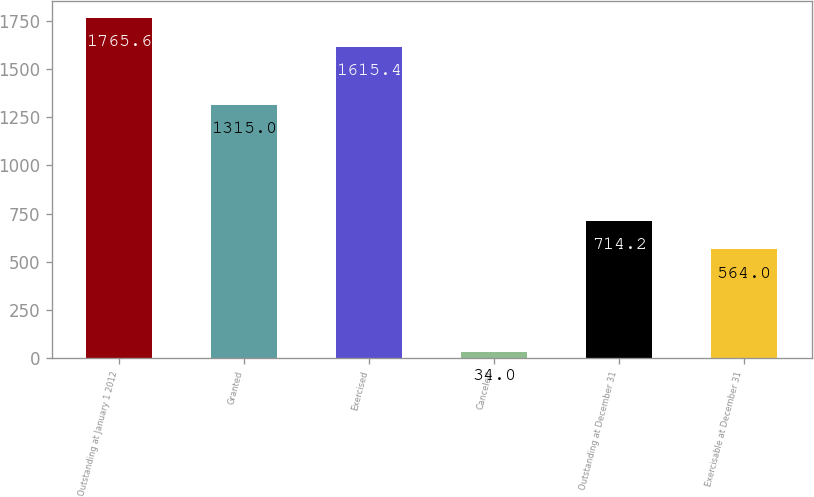<chart> <loc_0><loc_0><loc_500><loc_500><bar_chart><fcel>Outstanding at January 1 2012<fcel>Granted<fcel>Exercised<fcel>Canceled<fcel>Outstanding at December 31<fcel>Exercisable at December 31<nl><fcel>1765.6<fcel>1315<fcel>1615.4<fcel>34<fcel>714.2<fcel>564<nl></chart> 